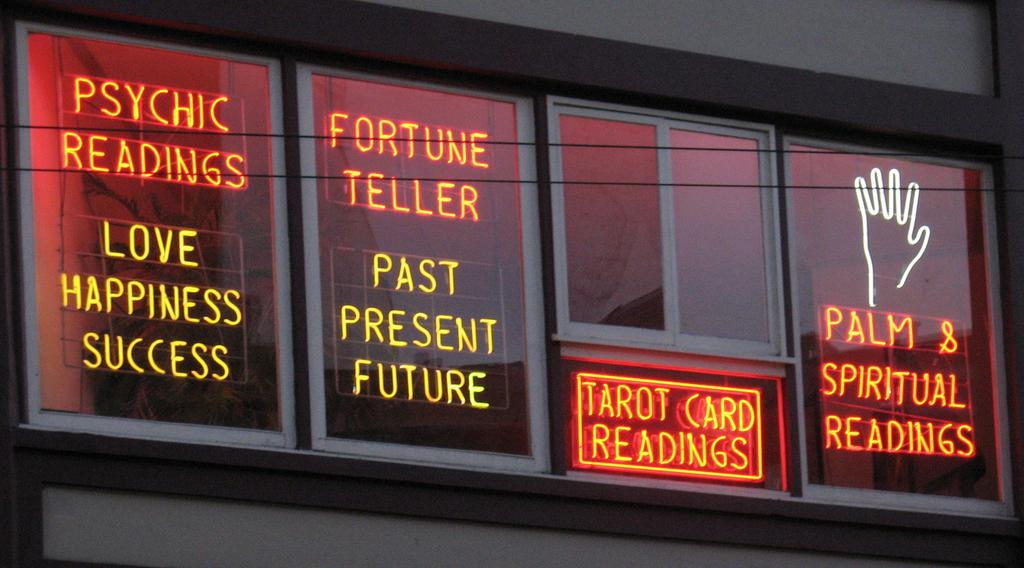<image>
Describe the image concisely. Psychic Readings and a Fortune Teller are available. 